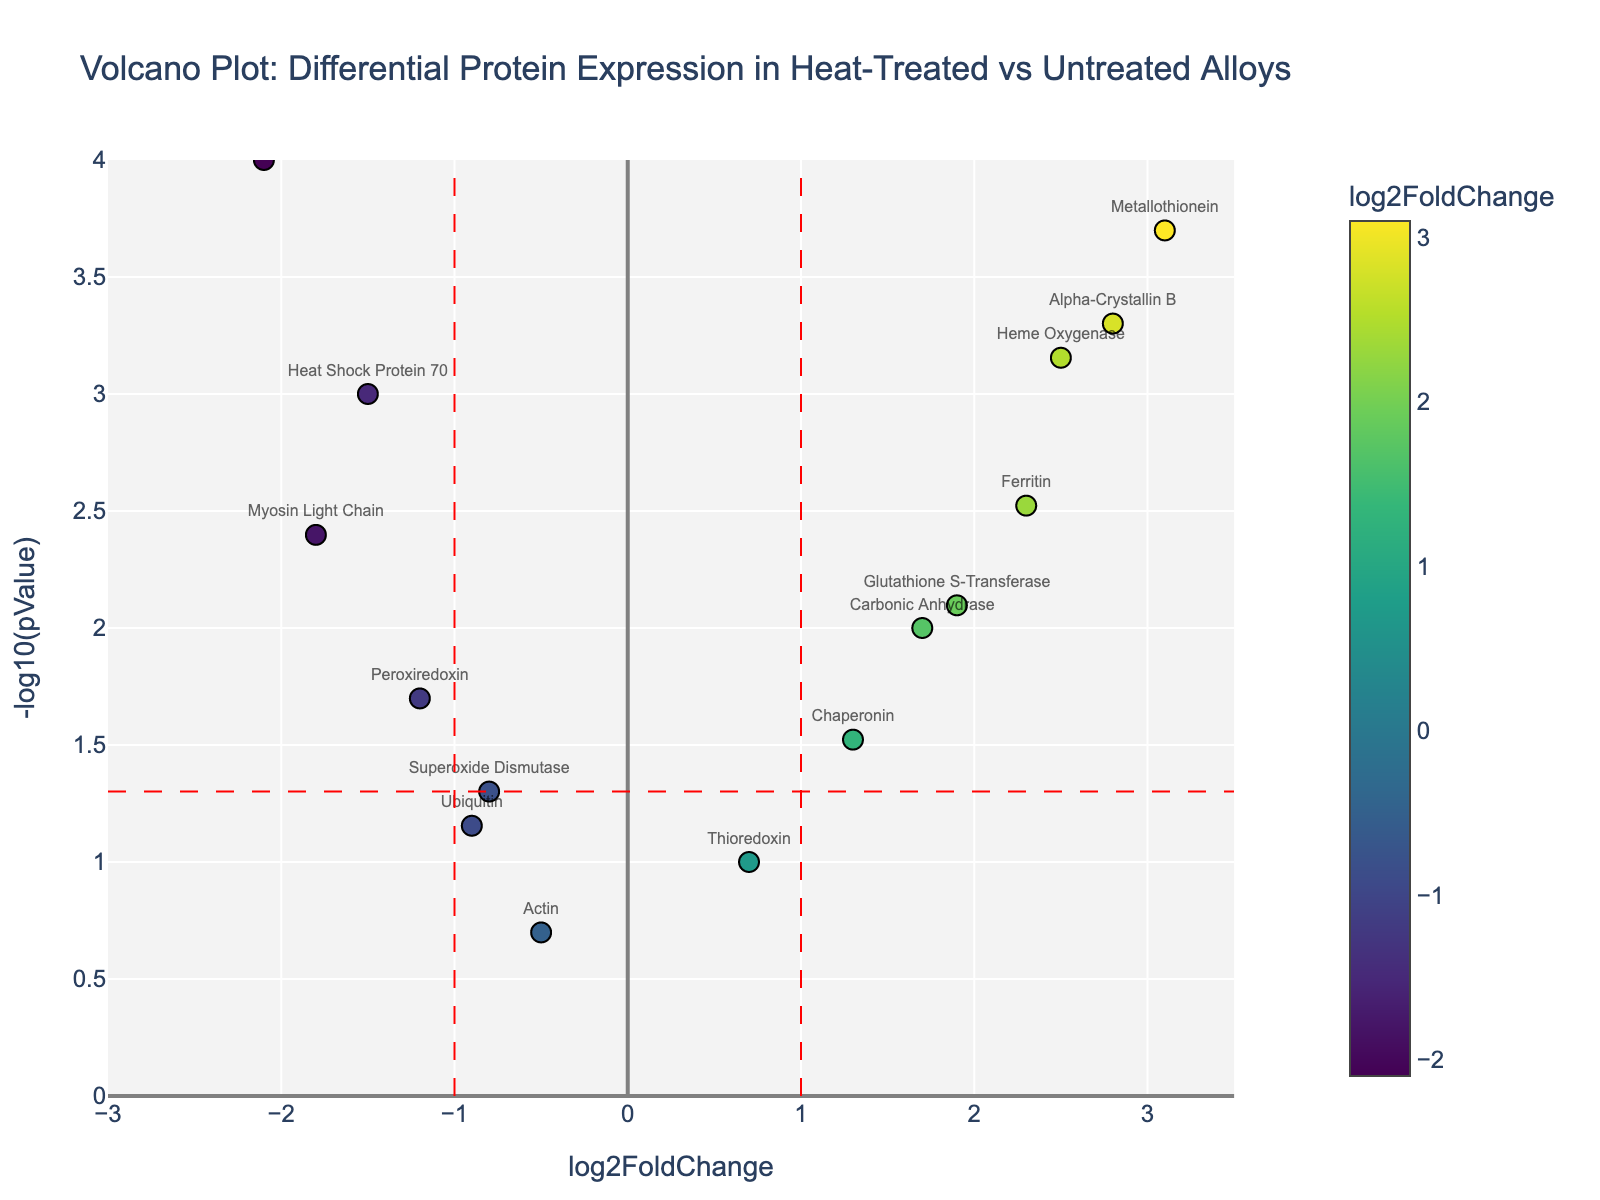What's the title of the volcano plot? The title of the plot is shown at the top center of the figure. It reads "Volcano Plot: Differential Protein Expression in Heat-Treated vs Untreated Alloys."
Answer: Volcano Plot: Differential Protein Expression in Heat-Treated vs Untreated Alloys How many proteins are significantly different at a p-value threshold of 0.05? Proteins above the horizontal red dash line ( -log10(pValue) = 1.3) are significant at a p-value threshold of 0.05. Count these data points.
Answer: 9 Which protein has the highest log2FoldChange? Find the protein with the highest x-axis value (log2FoldChange). Metallothionein has the highest log2FoldChange value.
Answer: Metallothionein How are the log2FoldChange values of "Heat Shock Protein 70" and "Ferritin" different? "Heat Shock Protein 70" has a log2FoldChange of -1.5, and "Ferritin" has a log2FoldChange of 2.3. Subtract the smaller from the larger. The difference is 2.3 - (-1.5) = 3.8.
Answer: 3.8 Which protein has the lowest p-value? The protein with the highest -log10(pValue) value on the y-axis corresponds to the lowest p-value. Metallothionein has the highest -log10(pValue).
Answer: Metallothionein What is the log2FoldChange of the protein "Catalase"? Locate the text for "Catalase" on the plot. The x-axis value corresponding to it is the log2FoldChange, which is -2.1.
Answer: -2.1 Are there more up-regulated or down-regulated proteins based on a log2FoldChange threshold of 1? Up-regulated proteins have log2FoldChange > 1, and down-regulated proteins have log2FoldChange < -1. Count the number of data points in each region.
Answer: More up-regulated How many proteins have a log2FoldChange between -1 and 1? Proteins with log2FoldChange between -1 and 1 fall between these two vertical red dash lines. Count these data points.
Answer: 5 Which protein is the closest to the significance threshold of p = 0.05 in terms of -log10(pValue)? The significance threshold is represented by the horizontal red dash line. "Superoxide Dismutase" is closest to this line.
Answer: Superoxide Dismutase 